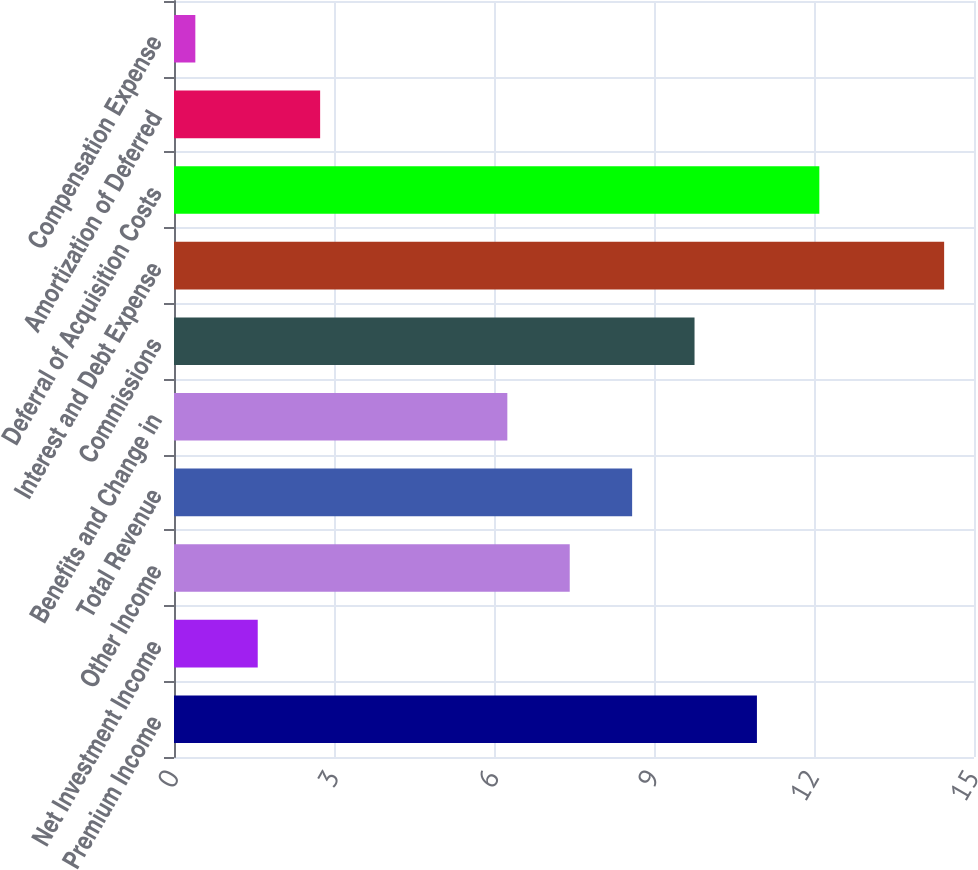Convert chart to OTSL. <chart><loc_0><loc_0><loc_500><loc_500><bar_chart><fcel>Premium Income<fcel>Net Investment Income<fcel>Other Income<fcel>Total Revenue<fcel>Benefits and Change in<fcel>Commissions<fcel>Interest and Debt Expense<fcel>Deferral of Acquisition Costs<fcel>Amortization of Deferred<fcel>Compensation Expense<nl><fcel>10.93<fcel>1.57<fcel>7.42<fcel>8.59<fcel>6.25<fcel>9.76<fcel>14.44<fcel>12.1<fcel>2.74<fcel>0.4<nl></chart> 